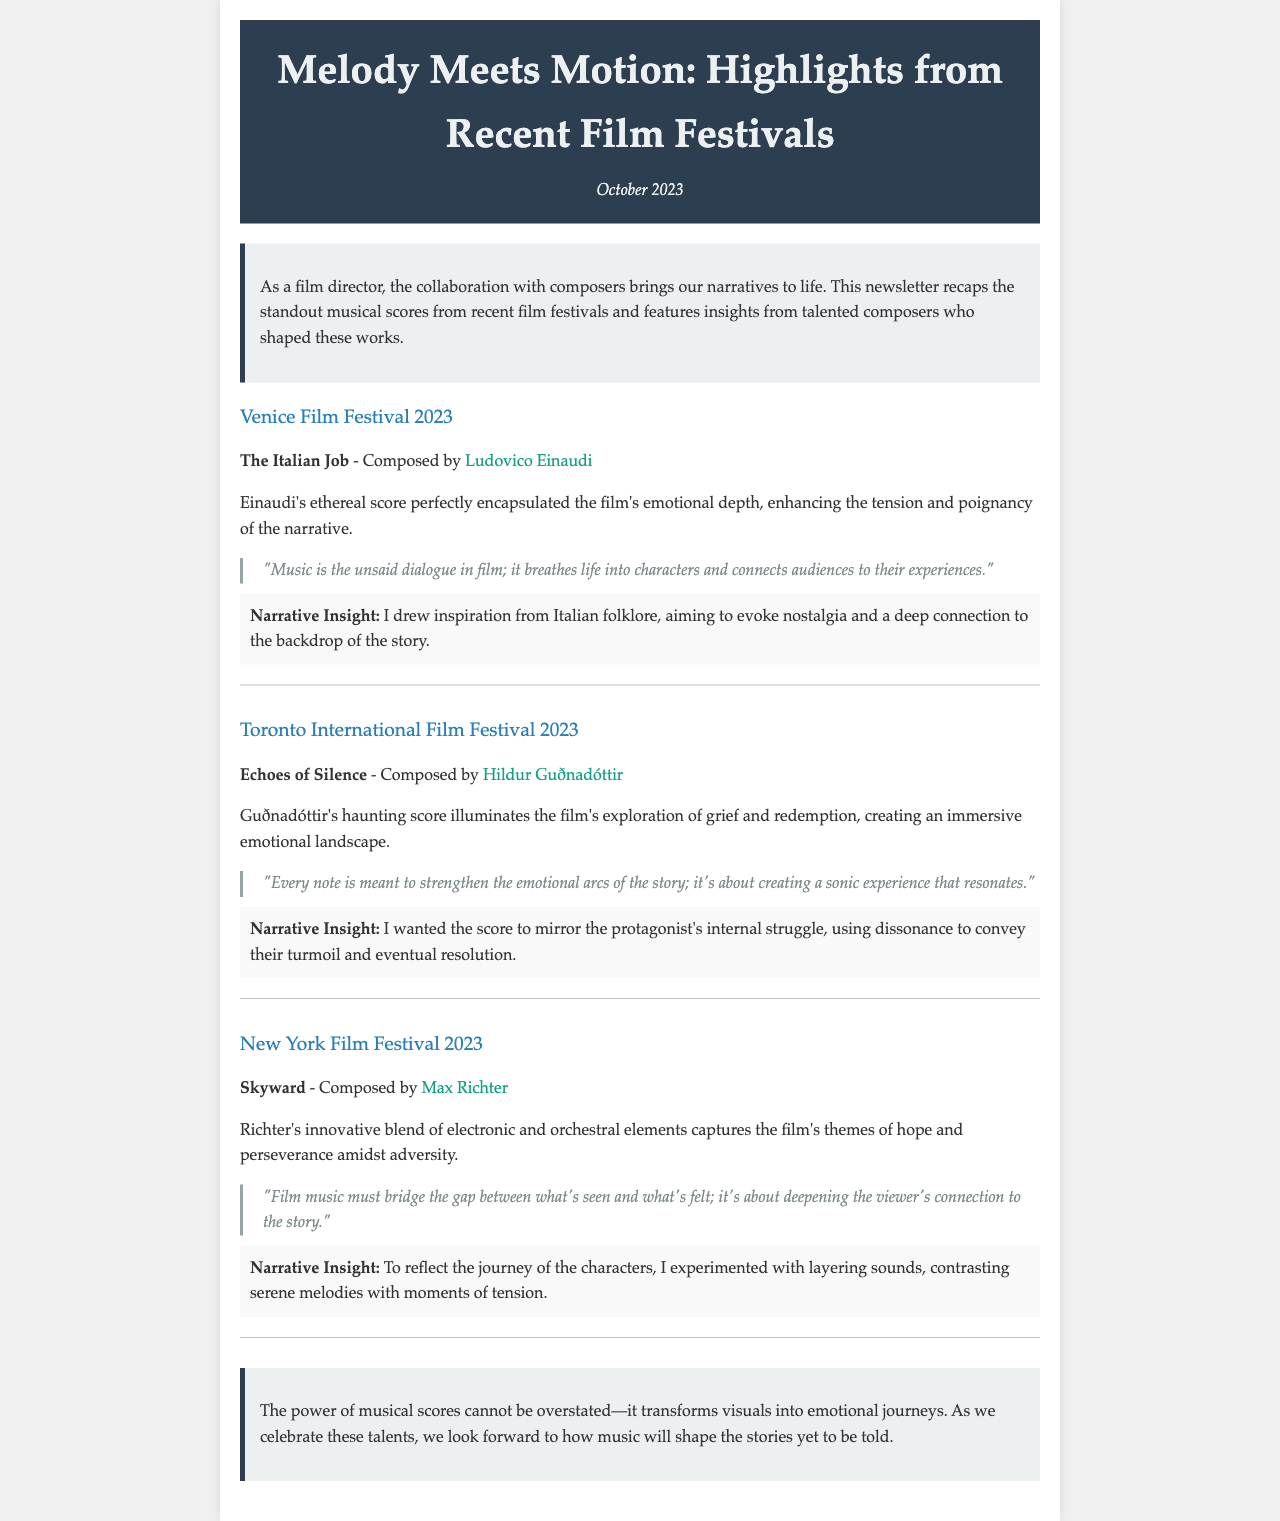what is the title of the newsletter? The title is prominently displayed at the top of the document, introducing the main theme of the content.
Answer: Melody Meets Motion: Highlights from Recent Film Festivals who composed the score for "The Italian Job"? The name of the composer is provided alongside the film title in the highlights section of the newsletter.
Answer: Ludovico Einaudi what festival highlighted "Echoes of Silence"? The festival name is stated as part of the highlight for the corresponding film within the newsletter.
Answer: Toronto International Film Festival 2023 how many composers are mentioned in the document? By counting the distinct composers from the highlighted films, we arrive at the total number present in the document.
Answer: Three what is the main emotional theme explored in "Skyward"? The highlight section describes the overarching themes of the film, indicating the emotional direction of the score.
Answer: Hope and perseverance what narrative element did Hildur Guðnadóttir emphasize in her composition? The insight section reveals the composer's intention regarding the narrative elements reflected in the score.
Answer: Internal struggle which festival took place in September 2023? The document recaps highlights from specific film festivals, one of which is linked to a festival date.
Answer: Venice Film Festival 2023 what is the date of the newsletter? The date is listed clearly in the header of the newsletter, establishing the specific timeline for the recap.
Answer: October 2023 